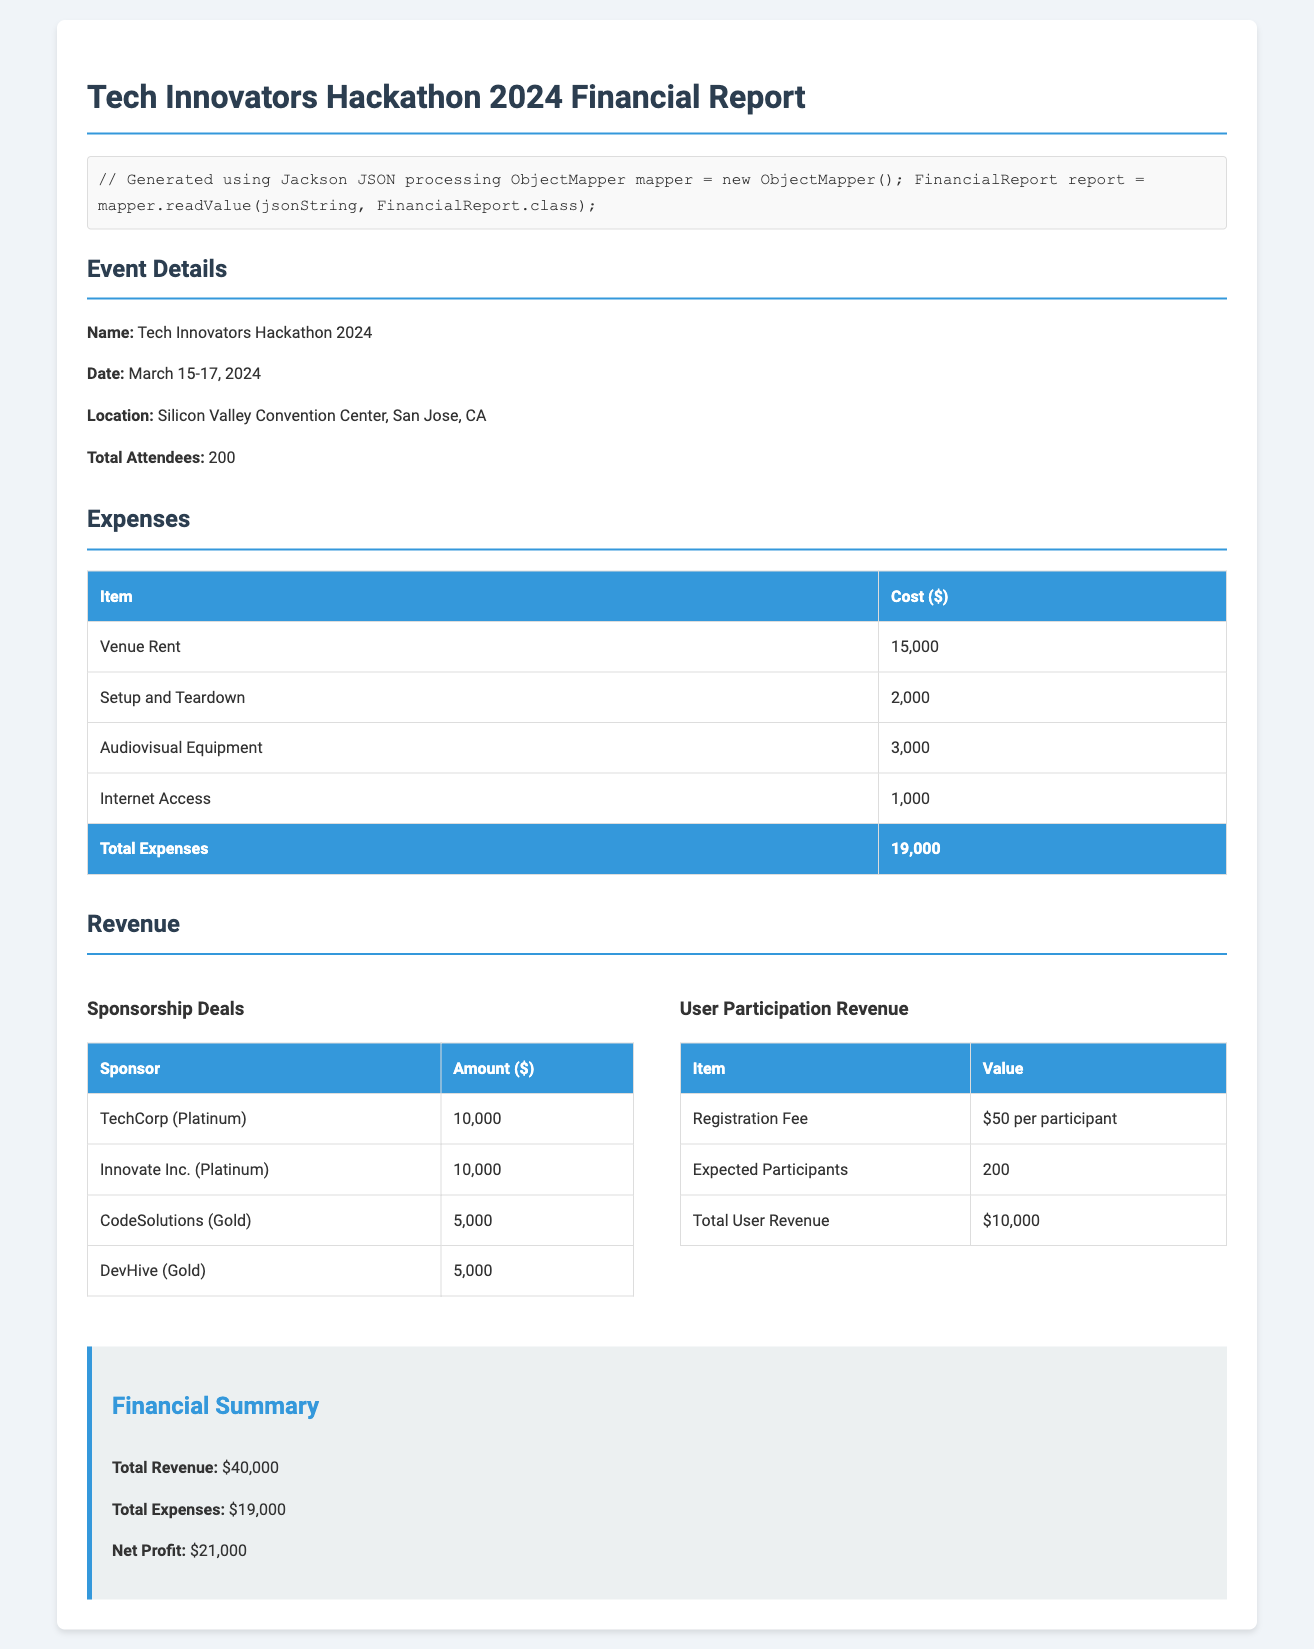What is the total expenses? The total expenses listed in the document add up to $19,000.
Answer: $19,000 What is the venue rent cost? The cost for venue rent is specifically stated as $15,000.
Answer: $15,000 How many expected participants are there? The document specifies 200 expected participants for the hackathon.
Answer: 200 What is the total user revenue? The total user revenue from participation is listed as $10,000.
Answer: $10,000 What is the net profit? The net profit is calculated as total revenue minus total expenses, equating to $21,000.
Answer: $21,000 What date does the hackathon occur? The event is scheduled from March 15-17, 2024.
Answer: March 15-17, 2024 How much did TechCorp sponsor the event? TechCorp provided a sponsorship of $10,000.
Answer: $10,000 What was the cost for audiovisual equipment? The cost listed for audiovisual equipment is $3,000.
Answer: $3,000 What is the registration fee per participant? The registration fee is detailed as $50 per participant.
Answer: $50 per participant 